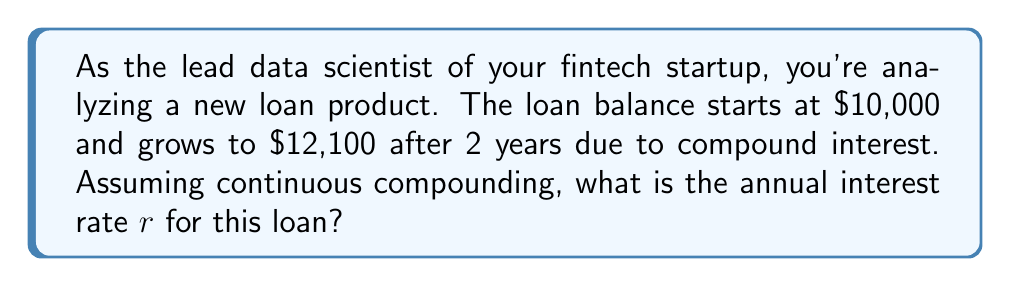Give your solution to this math problem. To solve this problem, we'll use the continuous compound interest formula:

$$A = P e^{rt}$$

Where:
$A$ = Final amount
$P$ = Principal (initial amount)
$r$ = Annual interest rate (as a decimal)
$t$ = Time in years
$e$ = Euler's number (approximately 2.71828)

Given:
$P = 10,000$
$A = 12,100$
$t = 2$ years

Step 1: Substitute the known values into the formula:
$$12,100 = 10,000 e^{r(2)}$$

Step 2: Divide both sides by 10,000:
$$1.21 = e^{2r}$$

Step 3: Take the natural logarithm of both sides:
$$\ln(1.21) = \ln(e^{2r})$$

Step 4: Simplify the right side using the logarithm property $\ln(e^x) = x$:
$$\ln(1.21) = 2r$$

Step 5: Solve for $r$:
$$r = \frac{\ln(1.21)}{2}$$

Step 6: Calculate the value of $r$:
$$r \approx 0.0954$$

Step 7: Convert to a percentage:
$$r \approx 9.54\%$$
Answer: $9.54\%$ 